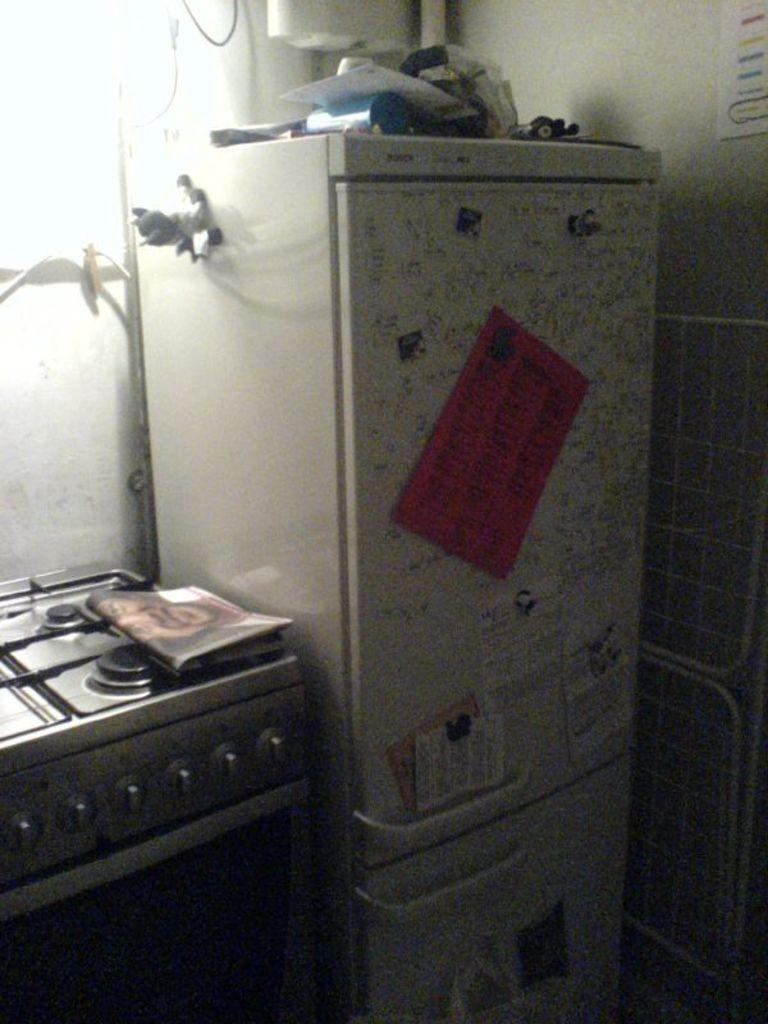What is placed on the stove in the image? There is paper on the stove. What can be seen on the refrigerator in the image? There are posters on the refrigerator. What is located above the refrigerator in the image? There are objects above the refrigerator. What is visible in the background of the image? There is a wall visible in the image. What type of plough is used to cultivate the wall in the image? There is no plough present in the image, and the wall is not being cultivated. What do you believe the objects above the refrigerator are used for? We cannot determine the purpose of the objects above the refrigerator from the image alone, as it is not mentioned in the provided facts. 